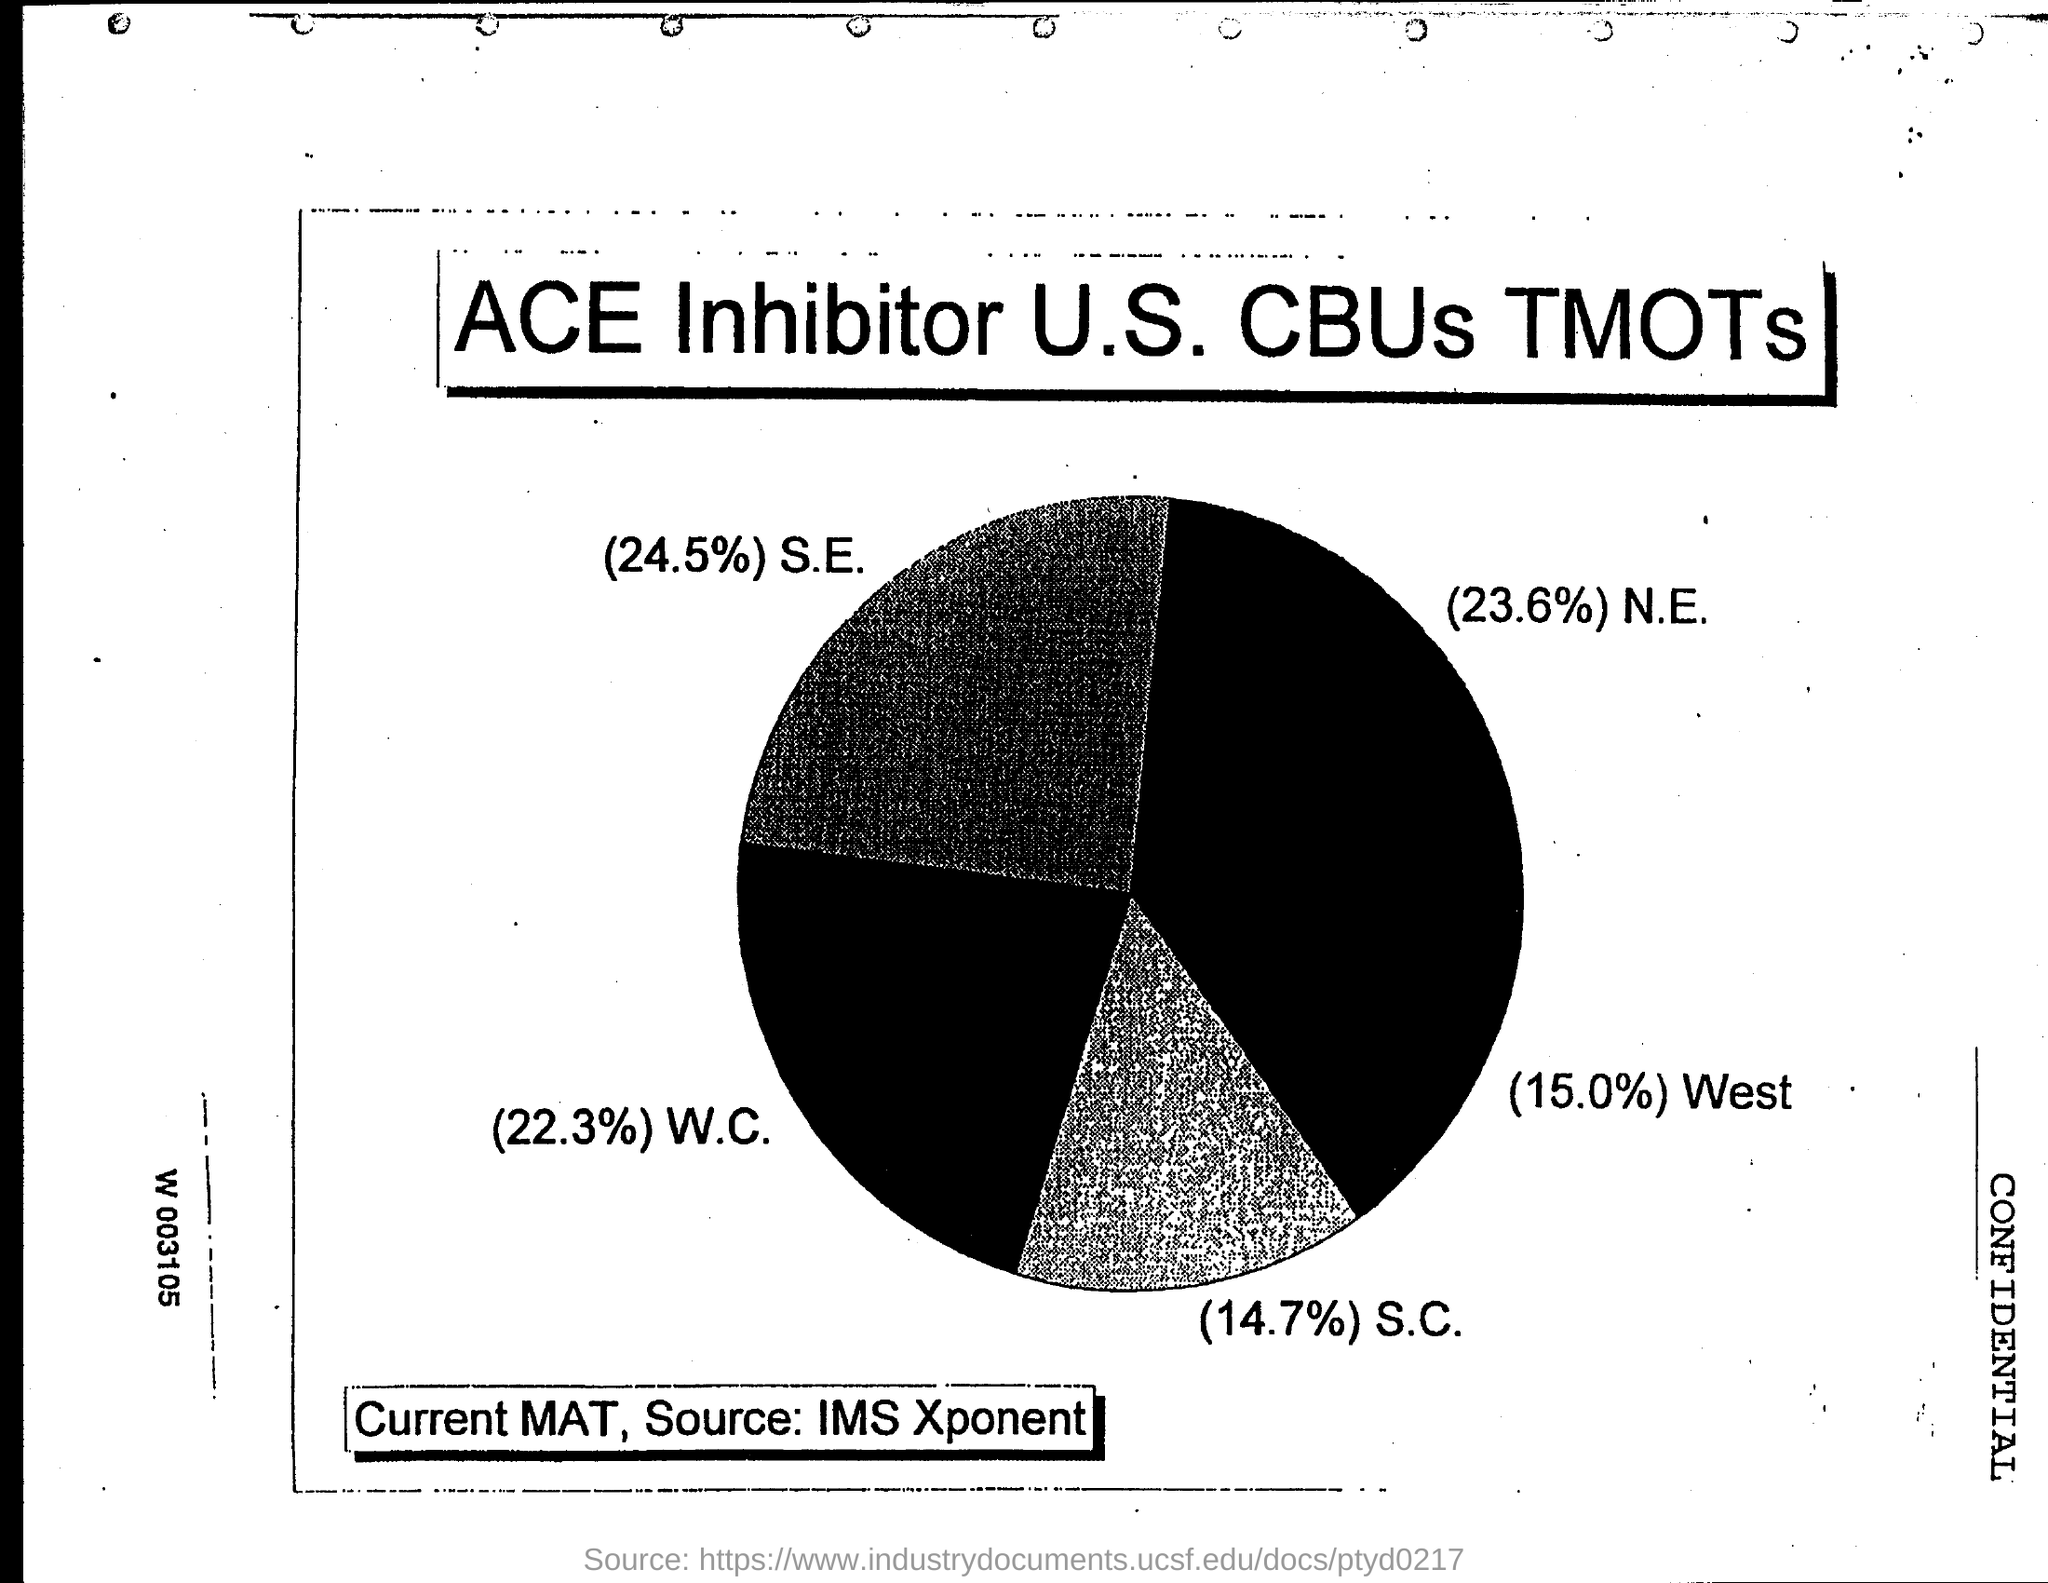Outline some significant characteristics in this image. In total, the Northeast region accounted for 23.6% of the overall production. In the West, the percentage is 15.0%. According to the information provided, 22.3% of the sampled population reported using W.C. products. The percentage of S.E is 24.5%. The percentage of S.C is 14.7%. 